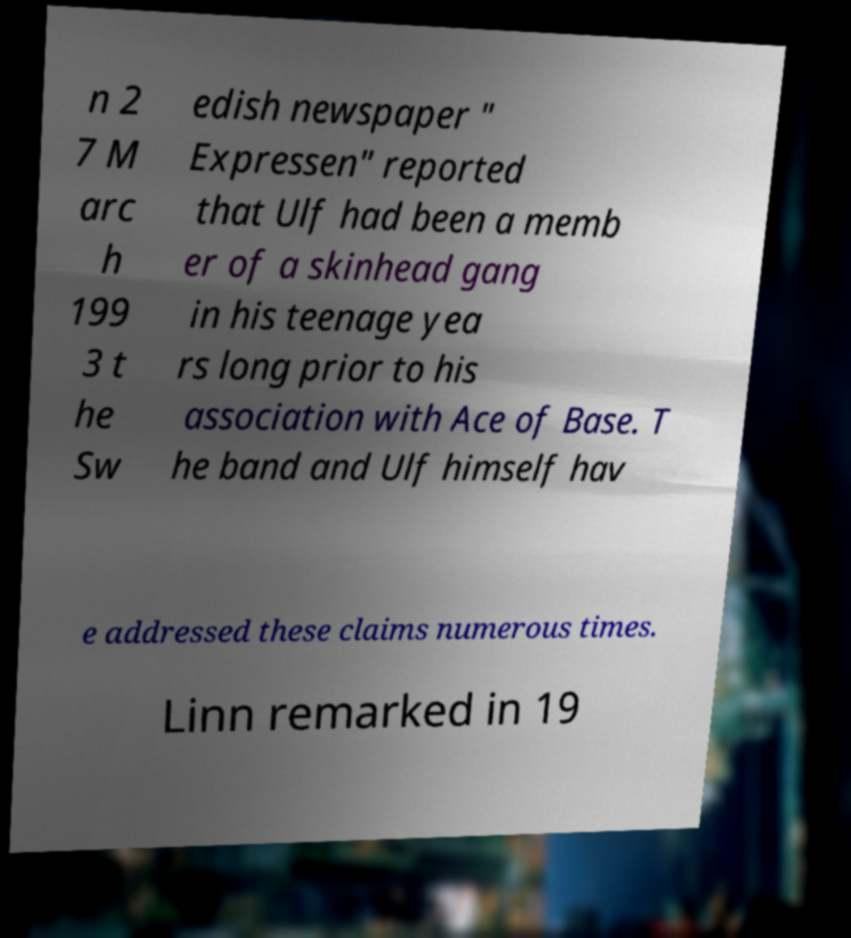Could you extract and type out the text from this image? n 2 7 M arc h 199 3 t he Sw edish newspaper " Expressen" reported that Ulf had been a memb er of a skinhead gang in his teenage yea rs long prior to his association with Ace of Base. T he band and Ulf himself hav e addressed these claims numerous times. Linn remarked in 19 